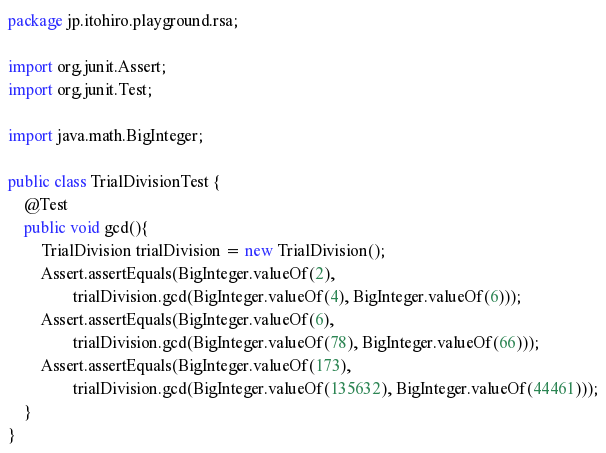<code> <loc_0><loc_0><loc_500><loc_500><_Java_>package jp.itohiro.playground.rsa;

import org.junit.Assert;
import org.junit.Test;

import java.math.BigInteger;

public class TrialDivisionTest {
    @Test
    public void gcd(){
        TrialDivision trialDivision = new TrialDivision();
        Assert.assertEquals(BigInteger.valueOf(2),
                trialDivision.gcd(BigInteger.valueOf(4), BigInteger.valueOf(6)));
        Assert.assertEquals(BigInteger.valueOf(6),
                trialDivision.gcd(BigInteger.valueOf(78), BigInteger.valueOf(66)));
        Assert.assertEquals(BigInteger.valueOf(173),
                trialDivision.gcd(BigInteger.valueOf(135632), BigInteger.valueOf(44461)));
    }
}
</code> 